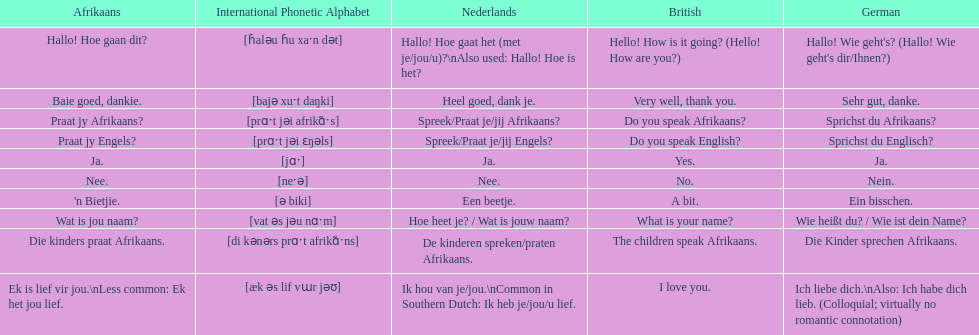How would you say the phrase the children speak afrikaans in afrikaans? Die kinders praat Afrikaans. How would you say the previous phrase in german? Die Kinder sprechen Afrikaans. 